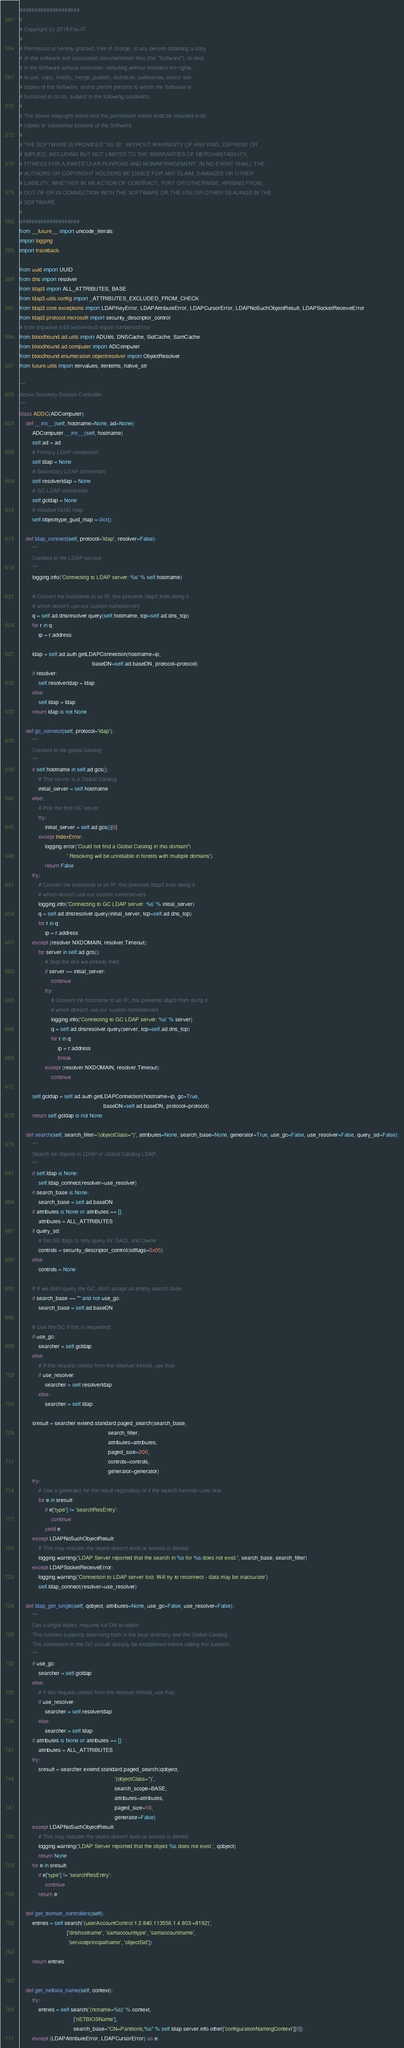<code> <loc_0><loc_0><loc_500><loc_500><_Python_>####################
#
# Copyright (c) 2018 Fox-IT
#
# Permission is hereby granted, free of charge, to any person obtaining a copy
# of this software and associated documentation files (the "Software"), to deal
# in the Software without restriction, including without limitation the rights
# to use, copy, modify, merge, publish, distribute, sublicense, and/or sell
# copies of the Software, and to permit persons to whom the Software is
# furnished to do so, subject to the following conditions:
#
# The above copyright notice and this permission notice shall be included in all
# copies or substantial portions of the Software.
#
# THE SOFTWARE IS PROVIDED "AS IS", WITHOUT WARRANTY OF ANY KIND, EXPRESS OR
# IMPLIED, INCLUDING BUT NOT LIMITED TO THE WARRANTIES OF MERCHANTABILITY,
# FITNESS FOR A PARTICULAR PURPOSE AND NONINFRINGEMENT. IN NO EVENT SHALL THE
# AUTHORS OR COPYRIGHT HOLDERS BE LIABLE FOR ANY CLAIM, DAMAGES OR OTHER
# LIABILITY, WHETHER IN AN ACTION OF CONTRACT, TORT OR OTHERWISE, ARISING FROM,
# OUT OF OR IN CONNECTION WITH THE SOFTWARE OR THE USE OR OTHER DEALINGS IN THE
# SOFTWARE.
#
####################
from __future__ import unicode_literals
import logging
import traceback

from uuid import UUID
from dns import resolver
from ldap3 import ALL_ATTRIBUTES, BASE
from ldap3.utils.config import _ATTRIBUTES_EXCLUDED_FROM_CHECK
from ldap3.core.exceptions import LDAPKeyError, LDAPAttributeError, LDAPCursorError, LDAPNoSuchObjectResult, LDAPSocketReceiveError
from ldap3.protocol.microsoft import security_descriptor_control
# from impacket.krb5.kerberosv5 import KerberosError
from bloodhound.ad.utils import ADUtils, DNSCache, SidCache, SamCache
from bloodhound.ad.computer import ADComputer
from bloodhound.enumeration.objectresolver import ObjectResolver
from future.utils import itervalues, iteritems, native_str

"""
Active Directory Domain Controller
"""
class ADDC(ADComputer):
    def __init__(self, hostname=None, ad=None):
        ADComputer.__init__(self, hostname)
        self.ad = ad
        # Primary LDAP connection
        self.ldap = None
        # Secondary LDAP connection
        self.resolverldap = None
        # GC LDAP connection
        self.gcldap = None
        # Initialize GUID map
        self.objecttype_guid_map = dict()

    def ldap_connect(self, protocol='ldap', resolver=False):
        """
        Connect to the LDAP service
        """
        logging.info('Connecting to LDAP server: %s' % self.hostname)

        # Convert the hostname to an IP, this prevents ldap3 from doing it
        # which doesn't use our custom nameservers
        q = self.ad.dnsresolver.query(self.hostname, tcp=self.ad.dns_tcp)
        for r in q:
            ip = r.address

        ldap = self.ad.auth.getLDAPConnection(hostname=ip,
                                              baseDN=self.ad.baseDN, protocol=protocol)
        if resolver:
            self.resolverldap = ldap
        else:
            self.ldap = ldap
        return ldap is not None

    def gc_connect(self, protocol='ldap'):
        """
        Connect to the global catalog
        """
        if self.hostname in self.ad.gcs():
            # This server is a Global Catalog
            initial_server = self.hostname
        else:
            # Pick the first GC server
            try:
                initial_server = self.ad.gcs()[0]
            except IndexError:
                logging.error('Could not find a Global Catalog in this domain!'\
                              ' Resolving will be unreliable in forests with multiple domains')
                return False
        try:
            # Convert the hostname to an IP, this prevents ldap3 from doing it
            # which doesn't use our custom nameservers
            logging.info('Connecting to GC LDAP server: %s' % initial_server)
            q = self.ad.dnsresolver.query(initial_server, tcp=self.ad.dns_tcp)
            for r in q:
                ip = r.address
        except (resolver.NXDOMAIN, resolver.Timeout):
            for server in self.ad.gcs():
                # Skip the one we already tried
                if server == initial_server:
                    continue
                try:
                    # Convert the hostname to an IP, this prevents ldap3 from doing it
                    # which doesn't use our custom nameservers
                    logging.info('Connecting to GC LDAP server: %s' % server)
                    q = self.ad.dnsresolver.query(server, tcp=self.ad.dns_tcp)
                    for r in q:
                        ip = r.address
                        break
                except (resolver.NXDOMAIN, resolver.Timeout):
                    continue

        self.gcldap = self.ad.auth.getLDAPConnection(hostname=ip, gc=True,
                                                     baseDN=self.ad.baseDN, protocol=protocol)
        return self.gcldap is not None

    def search(self, search_filter='(objectClass=*)', attributes=None, search_base=None, generator=True, use_gc=False, use_resolver=False, query_sd=False):
        """
        Search for objects in LDAP or Global Catalog LDAP.
        """
        if self.ldap is None:
            self.ldap_connect(resolver=use_resolver)
        if search_base is None:
            search_base = self.ad.baseDN
        if attributes is None or attributes == []:
            attributes = ALL_ATTRIBUTES
        if query_sd:
            # Set SD flags to only query for DACL and Owner
            controls = security_descriptor_control(sdflags=0x05)
        else:
            controls = None

        # If we don't query the GC, don't accept an empty search base
        if search_base == "" and not use_gc:
            search_base = self.ad.baseDN

        # Use the GC if this is requested
        if use_gc:
            searcher = self.gcldap
        else:
            # If this request comes from the resolver thread, use that
            if use_resolver:
                searcher = self.resolverldap
            else:
                searcher = self.ldap

        sresult = searcher.extend.standard.paged_search(search_base,
                                                        search_filter,
                                                        attributes=attributes,
                                                        paged_size=200,
                                                        controls=controls,
                                                        generator=generator)
        try:
            # Use a generator for the result regardless of if the search function uses one
            for e in sresult:
                if e['type'] != 'searchResEntry':
                    continue
                yield e
        except LDAPNoSuchObjectResult:
            # This may indicate the object doesn't exist or access is denied
            logging.warning('LDAP Server reported that the search in %s for %s does not exist.', search_base, search_filter)
        except LDAPSocketReceiveError:
            logging.warning('Connection to LDAP server lost. Will try to reconnect - data may be inaccurate')
            self.ldap_connect(resolver=use_resolver)

    def ldap_get_single(self, qobject, attributes=None, use_gc=False, use_resolver=False):
        """
        Get a single object, requires full DN to object.
        This function supports searching both in the local directory and the Global Catalog.
        The connection to the GC should already be established before calling this function.
        """
        if use_gc:
            searcher = self.gcldap
        else:
            # If this request comes from the resolver thread, use that
            if use_resolver:
                searcher = self.resolverldap
            else:
                searcher = self.ldap
        if attributes is None or attributes == []:
            attributes = ALL_ATTRIBUTES
        try:
            sresult = searcher.extend.standard.paged_search(qobject,
                                                            '(objectClass=*)',
                                                            search_scope=BASE,
                                                            attributes=attributes,
                                                            paged_size=10,
                                                            generator=False)
        except LDAPNoSuchObjectResult:
            # This may indicate the object doesn't exist or access is denied
            logging.warning('LDAP Server reported that the object %s does not exist.', qobject)
            return None
        for e in sresult:
            if e['type'] != 'searchResEntry':
                continue
            return e

    def get_domain_controllers(self):
        entries = self.search('(userAccountControl:1.2.840.113556.1.4.803:=8192)',
                              ['dnshostname', 'samaccounttype', 'samaccountname',
                               'serviceprincipalname', 'objectSid'])

        return entries


    def get_netbios_name(self, context):
        try:
            entries = self.search('(ncname=%s)' % context,
                                  ['nETBIOSName'],
                                  search_base="CN=Partitions,%s" % self.ldap.server.info.other['configurationNamingContext'][0])
        except (LDAPAttributeError, LDAPCursorError) as e:</code> 